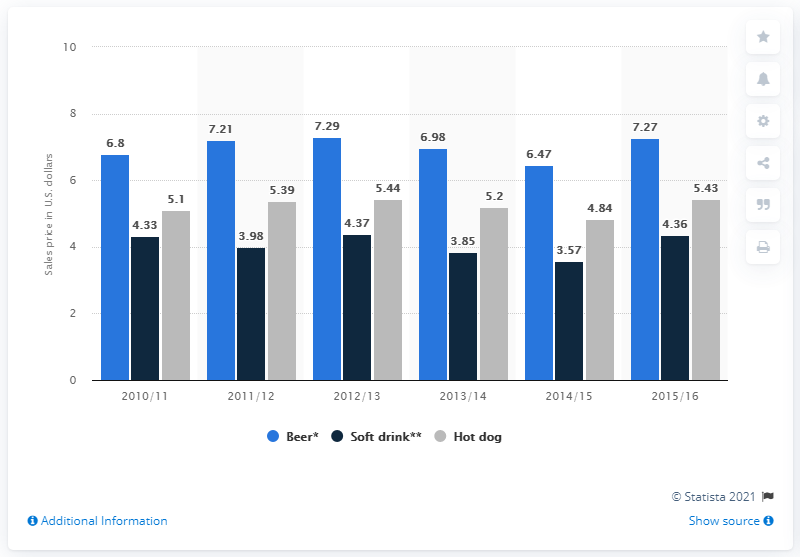Point out several critical features in this image. During the 2012/2013 season, the cost of a 16 ounce beer was approximately 7.29 dollars. The difference between beer consumed in 2015 and beer consumed in 2010 is 0.47... The highly consumed drink is beer. 